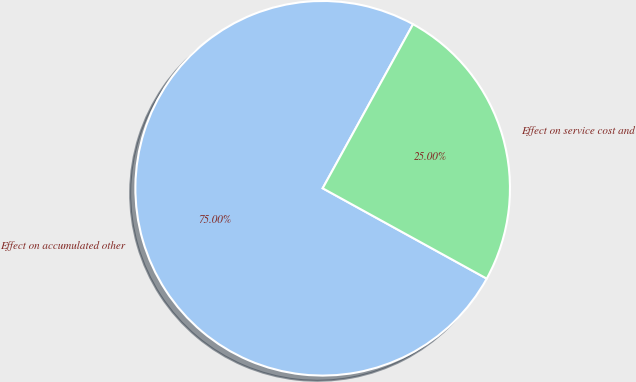Convert chart to OTSL. <chart><loc_0><loc_0><loc_500><loc_500><pie_chart><fcel>Effect on accumulated other<fcel>Effect on service cost and<nl><fcel>75.0%<fcel>25.0%<nl></chart> 